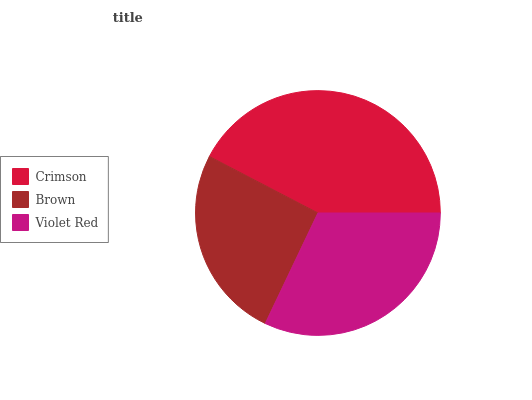Is Brown the minimum?
Answer yes or no. Yes. Is Crimson the maximum?
Answer yes or no. Yes. Is Violet Red the minimum?
Answer yes or no. No. Is Violet Red the maximum?
Answer yes or no. No. Is Violet Red greater than Brown?
Answer yes or no. Yes. Is Brown less than Violet Red?
Answer yes or no. Yes. Is Brown greater than Violet Red?
Answer yes or no. No. Is Violet Red less than Brown?
Answer yes or no. No. Is Violet Red the high median?
Answer yes or no. Yes. Is Violet Red the low median?
Answer yes or no. Yes. Is Brown the high median?
Answer yes or no. No. Is Crimson the low median?
Answer yes or no. No. 